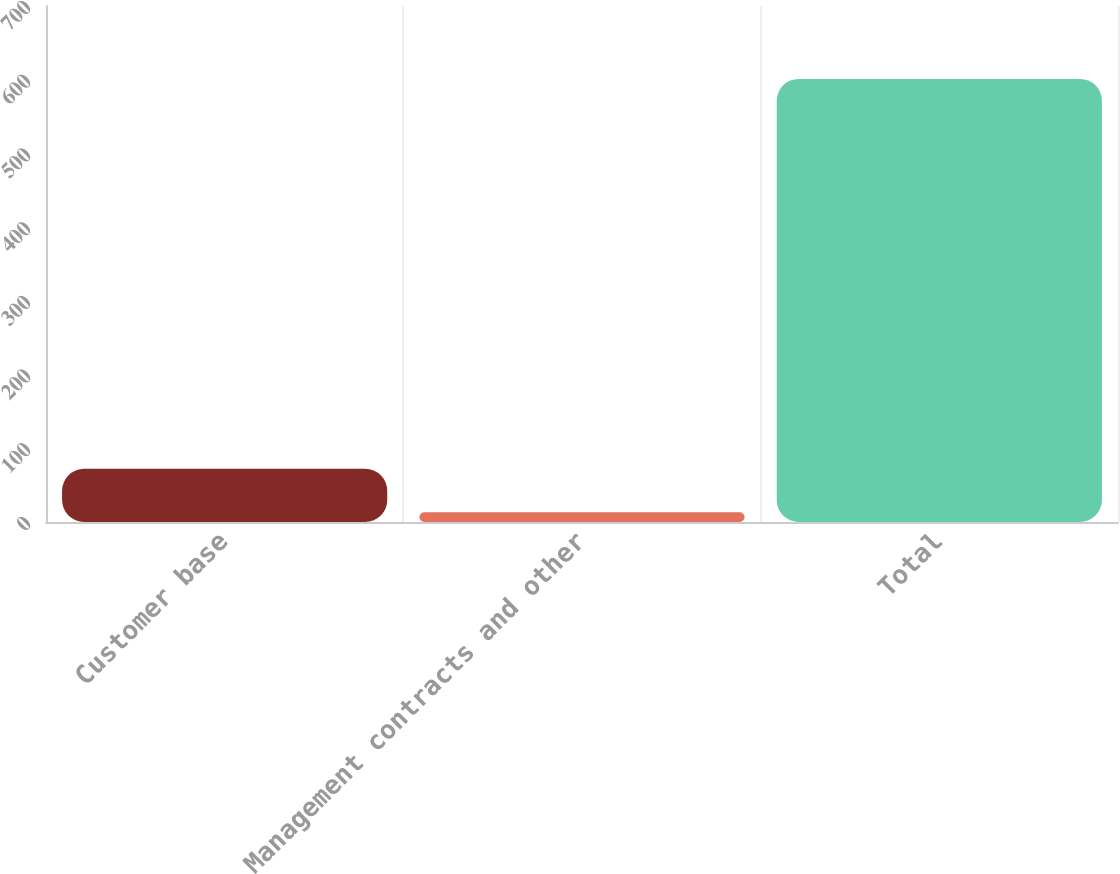Convert chart to OTSL. <chart><loc_0><loc_0><loc_500><loc_500><bar_chart><fcel>Customer base<fcel>Management contracts and other<fcel>Total<nl><fcel>72.08<fcel>13.3<fcel>601.1<nl></chart> 